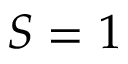<formula> <loc_0><loc_0><loc_500><loc_500>S = 1</formula> 